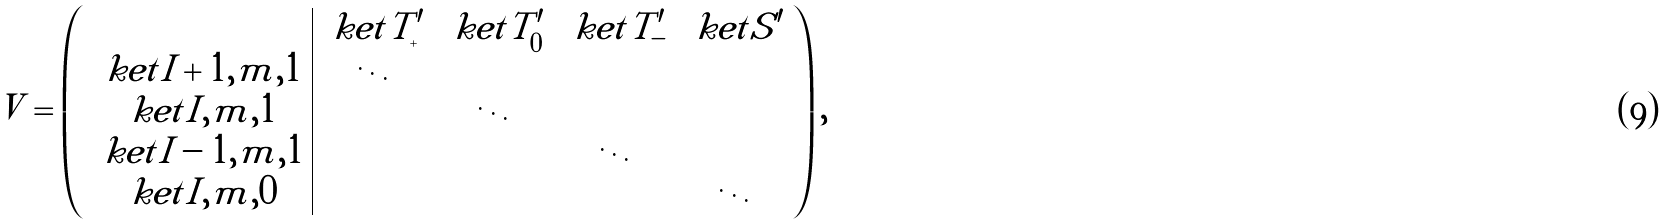Convert formula to latex. <formula><loc_0><loc_0><loc_500><loc_500>V = \left ( \begin{array} { c | c c c c } & \ k e t { T ^ { \prime } _ { + } } & \ k e t { T ^ { \prime } _ { 0 } } & \ k e t { T ^ { \prime } _ { - } } & \ k e t { S ^ { \prime } } \\ \ k e t { I + 1 , m , 1 } & \ddots & & & \\ \ k e t { I , m , 1 } & & \ddots & & \\ \ k e t { I - 1 , m , 1 } & & & \ddots & \\ \ k e t { I , m , 0 } & & & & \ddots \end{array} \right ) ,</formula> 